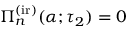Convert formula to latex. <formula><loc_0><loc_0><loc_500><loc_500>\Pi _ { n } ^ { ( i r ) } ( \alpha ; \tau _ { 2 } ) = 0</formula> 